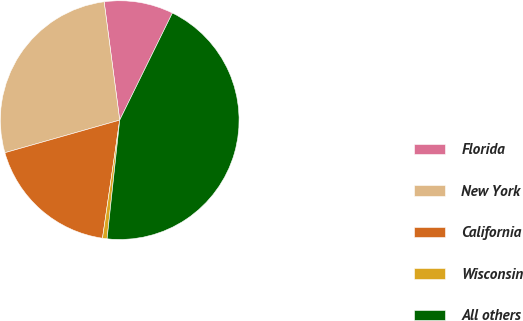Convert chart. <chart><loc_0><loc_0><loc_500><loc_500><pie_chart><fcel>Florida<fcel>New York<fcel>California<fcel>Wisconsin<fcel>All others<nl><fcel>9.36%<fcel>27.32%<fcel>18.29%<fcel>0.62%<fcel>44.41%<nl></chart> 